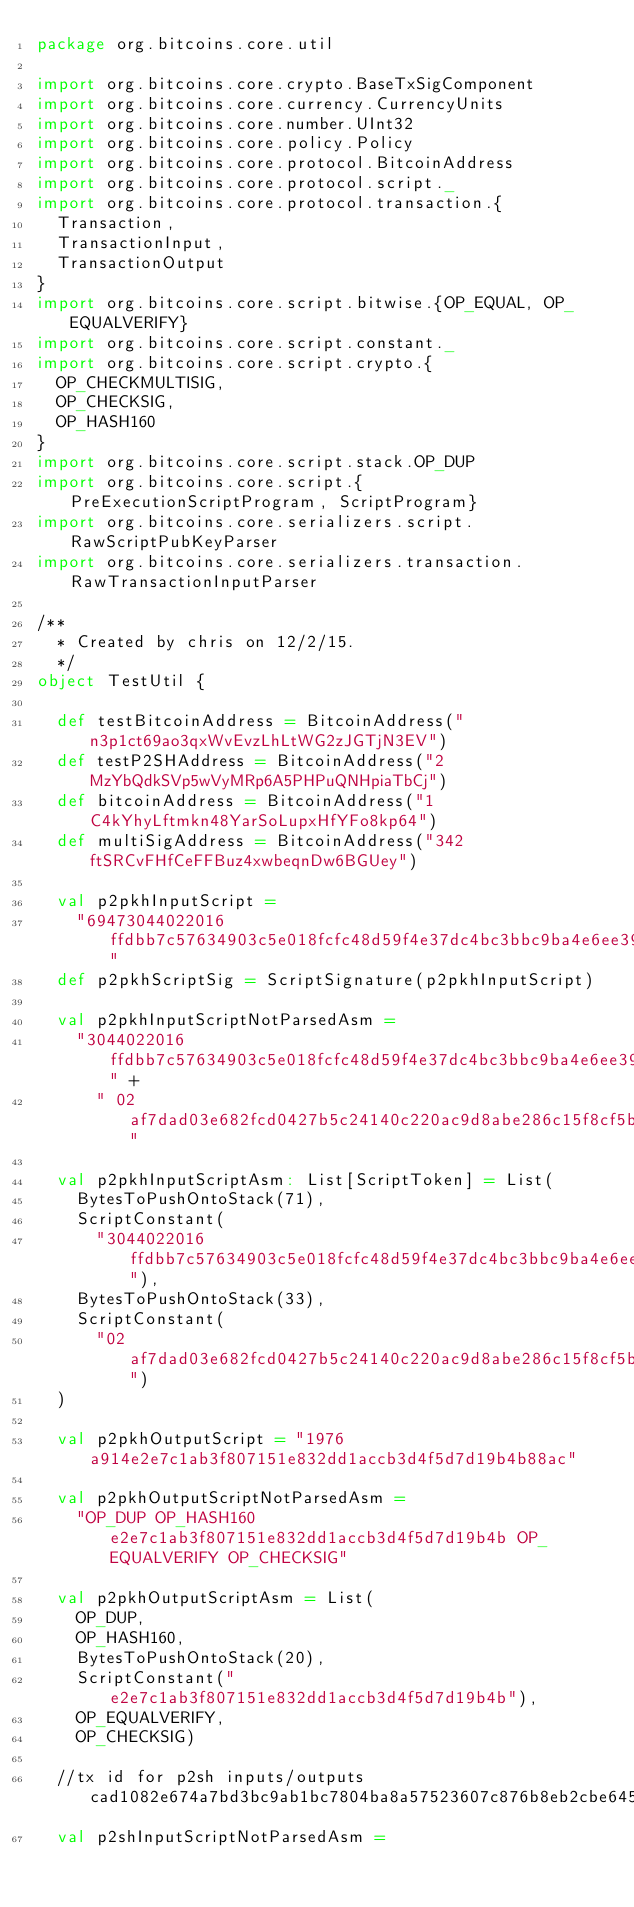Convert code to text. <code><loc_0><loc_0><loc_500><loc_500><_Scala_>package org.bitcoins.core.util

import org.bitcoins.core.crypto.BaseTxSigComponent
import org.bitcoins.core.currency.CurrencyUnits
import org.bitcoins.core.number.UInt32
import org.bitcoins.core.policy.Policy
import org.bitcoins.core.protocol.BitcoinAddress
import org.bitcoins.core.protocol.script._
import org.bitcoins.core.protocol.transaction.{
  Transaction,
  TransactionInput,
  TransactionOutput
}
import org.bitcoins.core.script.bitwise.{OP_EQUAL, OP_EQUALVERIFY}
import org.bitcoins.core.script.constant._
import org.bitcoins.core.script.crypto.{
  OP_CHECKMULTISIG,
  OP_CHECKSIG,
  OP_HASH160
}
import org.bitcoins.core.script.stack.OP_DUP
import org.bitcoins.core.script.{PreExecutionScriptProgram, ScriptProgram}
import org.bitcoins.core.serializers.script.RawScriptPubKeyParser
import org.bitcoins.core.serializers.transaction.RawTransactionInputParser

/**
  * Created by chris on 12/2/15.
  */
object TestUtil {

  def testBitcoinAddress = BitcoinAddress("n3p1ct69ao3qxWvEvzLhLtWG2zJGTjN3EV")
  def testP2SHAddress = BitcoinAddress("2MzYbQdkSVp5wVyMRp6A5PHPuQNHpiaTbCj")
  def bitcoinAddress = BitcoinAddress("1C4kYhyLftmkn48YarSoLupxHfYFo8kp64")
  def multiSigAddress = BitcoinAddress("342ftSRCvFHfCeFFBuz4xwbeqnDw6BGUey")

  val p2pkhInputScript =
    "69473044022016ffdbb7c57634903c5e018fcfc48d59f4e37dc4bc3bbc9ba4e6ee39150bca030220119c2241a931819bc1a75d3596e4029d803d1cd6de123bf8a1a1a2c3665e1fac012102af7dad03e682fcd0427b5c24140c220ac9d8abe286c15f8cf5bf77eed19c3652"
  def p2pkhScriptSig = ScriptSignature(p2pkhInputScript)

  val p2pkhInputScriptNotParsedAsm =
    "3044022016ffdbb7c57634903c5e018fcfc48d59f4e37dc4bc3bbc9ba4e6ee39150bca030220119c2241a931819bc1a75d3596e4029d803d1cd6de123bf8a1a1a2c3665e1fac01" +
      " 02af7dad03e682fcd0427b5c24140c220ac9d8abe286c15f8cf5bf77eed19c3652"

  val p2pkhInputScriptAsm: List[ScriptToken] = List(
    BytesToPushOntoStack(71),
    ScriptConstant(
      "3044022016ffdbb7c57634903c5e018fcfc48d59f4e37dc4bc3bbc9ba4e6ee39150bca030220119c2241a931819bc1a75d3596e4029d803d1cd6de123bf8a1a1a2c3665e1fac01"),
    BytesToPushOntoStack(33),
    ScriptConstant(
      "02af7dad03e682fcd0427b5c24140c220ac9d8abe286c15f8cf5bf77eed19c3652")
  )

  val p2pkhOutputScript = "1976a914e2e7c1ab3f807151e832dd1accb3d4f5d7d19b4b88ac"

  val p2pkhOutputScriptNotParsedAsm =
    "OP_DUP OP_HASH160 e2e7c1ab3f807151e832dd1accb3d4f5d7d19b4b OP_EQUALVERIFY OP_CHECKSIG"

  val p2pkhOutputScriptAsm = List(
    OP_DUP,
    OP_HASH160,
    BytesToPushOntoStack(20),
    ScriptConstant("e2e7c1ab3f807151e832dd1accb3d4f5d7d19b4b"),
    OP_EQUALVERIFY,
    OP_CHECKSIG)

  //tx id for p2sh inputs/outputs cad1082e674a7bd3bc9ab1bc7804ba8a57523607c876b8eb2cbe645f2b1803d6
  val p2shInputScriptNotParsedAsm =</code> 